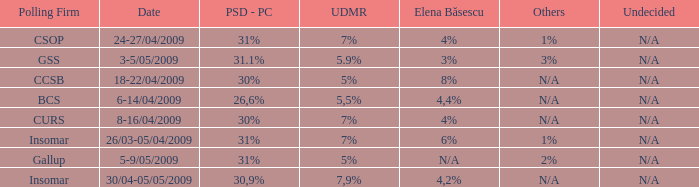What was the UDMR for 18-22/04/2009? 5%. 